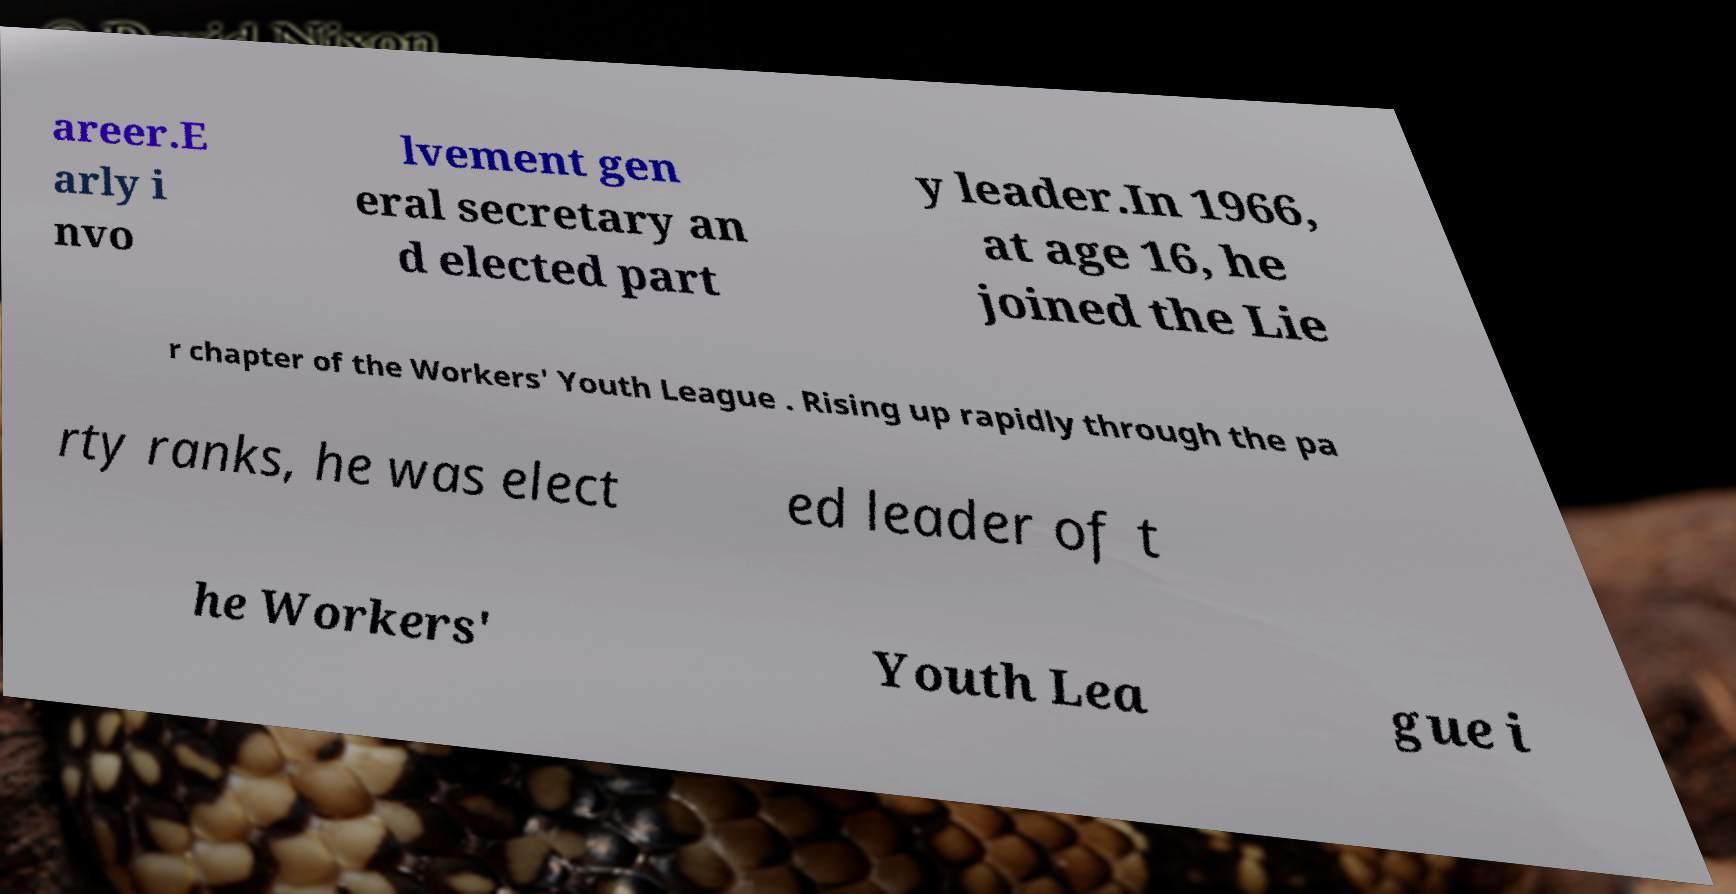There's text embedded in this image that I need extracted. Can you transcribe it verbatim? areer.E arly i nvo lvement gen eral secretary an d elected part y leader.In 1966, at age 16, he joined the Lie r chapter of the Workers' Youth League . Rising up rapidly through the pa rty ranks, he was elect ed leader of t he Workers' Youth Lea gue i 